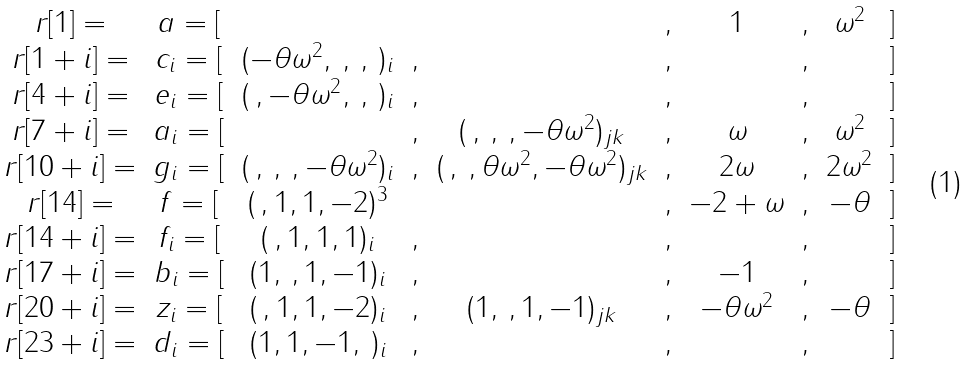<formula> <loc_0><loc_0><loc_500><loc_500>\begin{matrix} r [ 1 ] = & a = [ & & & & , & 1 & , & \omega ^ { 2 } & ] \\ r [ 1 + i ] = & c _ { i } = [ & ( - \theta \omega ^ { 2 } , \, , \, , \, ) _ { i } & , & & , & & , & & ] \\ r [ 4 + i ] = & e _ { i } = [ & ( \, , - \theta \omega ^ { 2 } , \, , \, ) _ { i } & , & & , & & , & & ] \\ r [ 7 + i ] = & a _ { i } = [ & & , & ( \, , \, , \, , - \theta \omega ^ { 2 } ) _ { j k } & , & \omega & , & \omega ^ { 2 } & ] \\ r [ 1 0 + i ] = & g _ { i } = [ & ( \, , \, , \, , - \theta \omega ^ { 2 } ) _ { i } & , & ( \, , \, , \theta \omega ^ { 2 } , - \theta \omega ^ { 2 } ) _ { j k } & , & 2 \omega & , & 2 \omega ^ { 2 } & ] \\ r [ 1 4 ] = & f = [ & ( \, , 1 , 1 , - 2 ) ^ { 3 } & & & , & - 2 + \omega & , & - \theta & ] \\ r [ 1 4 + i ] = & f _ { i } = [ & ( \, , 1 , 1 , 1 ) _ { i } & , & & , & & , & & ] \\ r [ 1 7 + i ] = & b _ { i } = [ & ( 1 , \, , 1 , - 1 ) _ { i } & , & & , & - 1 & , & & ] \\ r [ 2 0 + i ] = & z _ { i } = [ & ( \, , 1 , 1 , - 2 ) _ { i } & , & ( 1 , \, , 1 , - 1 ) _ { j k } & , & - \theta \omega ^ { 2 } & , & - \theta & ] \\ r [ 2 3 + i ] = & d _ { i } = [ & ( 1 , 1 , - 1 , \, ) _ { i } & , & & , & & , & & ] \\ \end{matrix}</formula> 